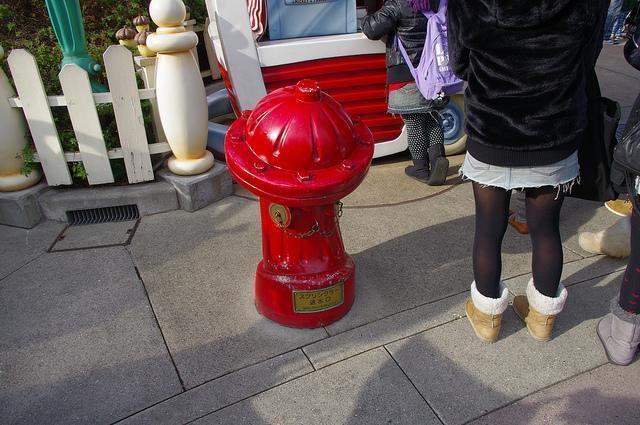What is required to open the flow of water?
Pick the correct solution from the four options below to address the question.
Options: Wrench, saw, hammer, drill. Wrench. 